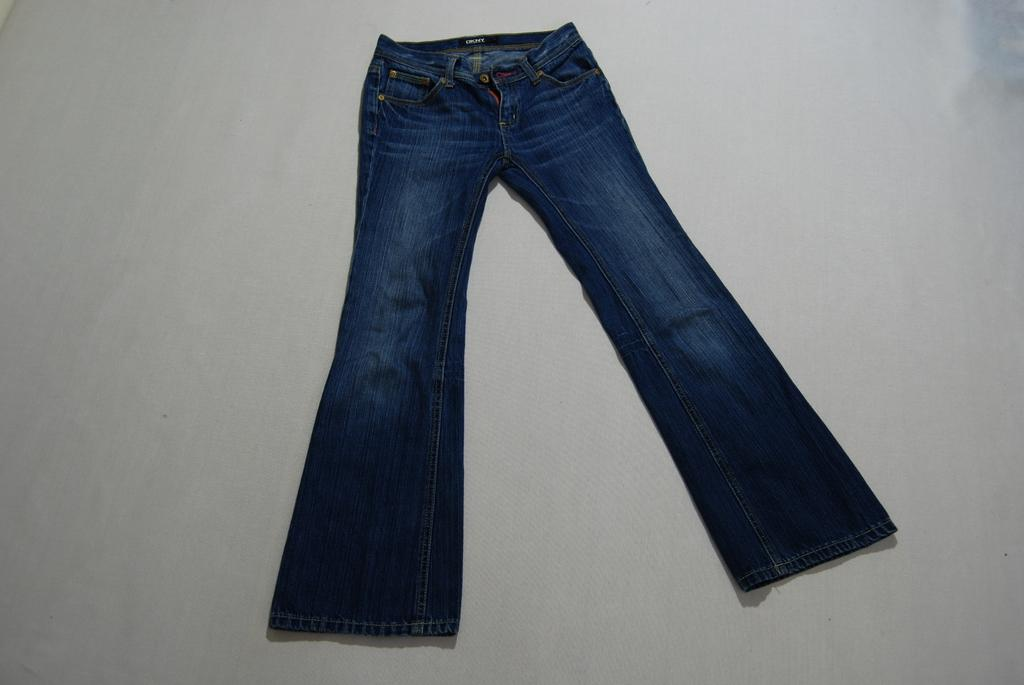What type of clothing item is in the image? There is a jean in the image. Where is the jean placed in the image? The jean is placed on a plain surface. What type of agreement is being discussed in the image? There is no discussion or agreement present in the image; it only shows a jean placed on a plain surface. 